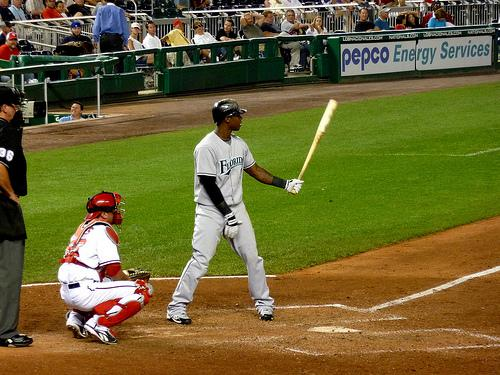Question: what color is the batters helmet?
Choices:
A. Blue.
B. Black.
C. Gray.
D. White.
Answer with the letter. Answer: B Question: where is the game being played?
Choices:
A. In the park.
B. On the beach.
C. In the arena.
D. Baseball field.
Answer with the letter. Answer: D Question: where is this taking place?
Choices:
A. On the ice rink.
B. In a basketball arena.
C. At the baseball field.
D. In a football stadium.
Answer with the letter. Answer: C 